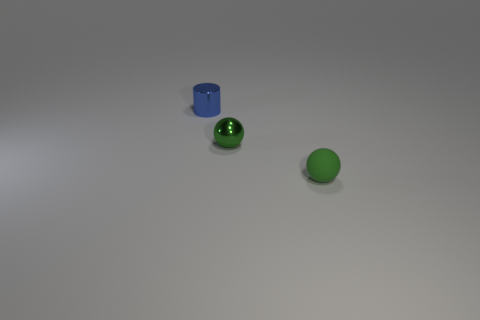Add 1 small blue cylinders. How many small blue cylinders are left? 2 Add 2 small blue things. How many small blue things exist? 3 Add 1 blue cylinders. How many objects exist? 4 Subtract 0 brown cylinders. How many objects are left? 3 Subtract all cylinders. How many objects are left? 2 Subtract 1 cylinders. How many cylinders are left? 0 Subtract all brown balls. Subtract all purple cubes. How many balls are left? 2 Subtract all brown balls. How many gray cylinders are left? 0 Subtract all small green matte balls. Subtract all tiny green spheres. How many objects are left? 0 